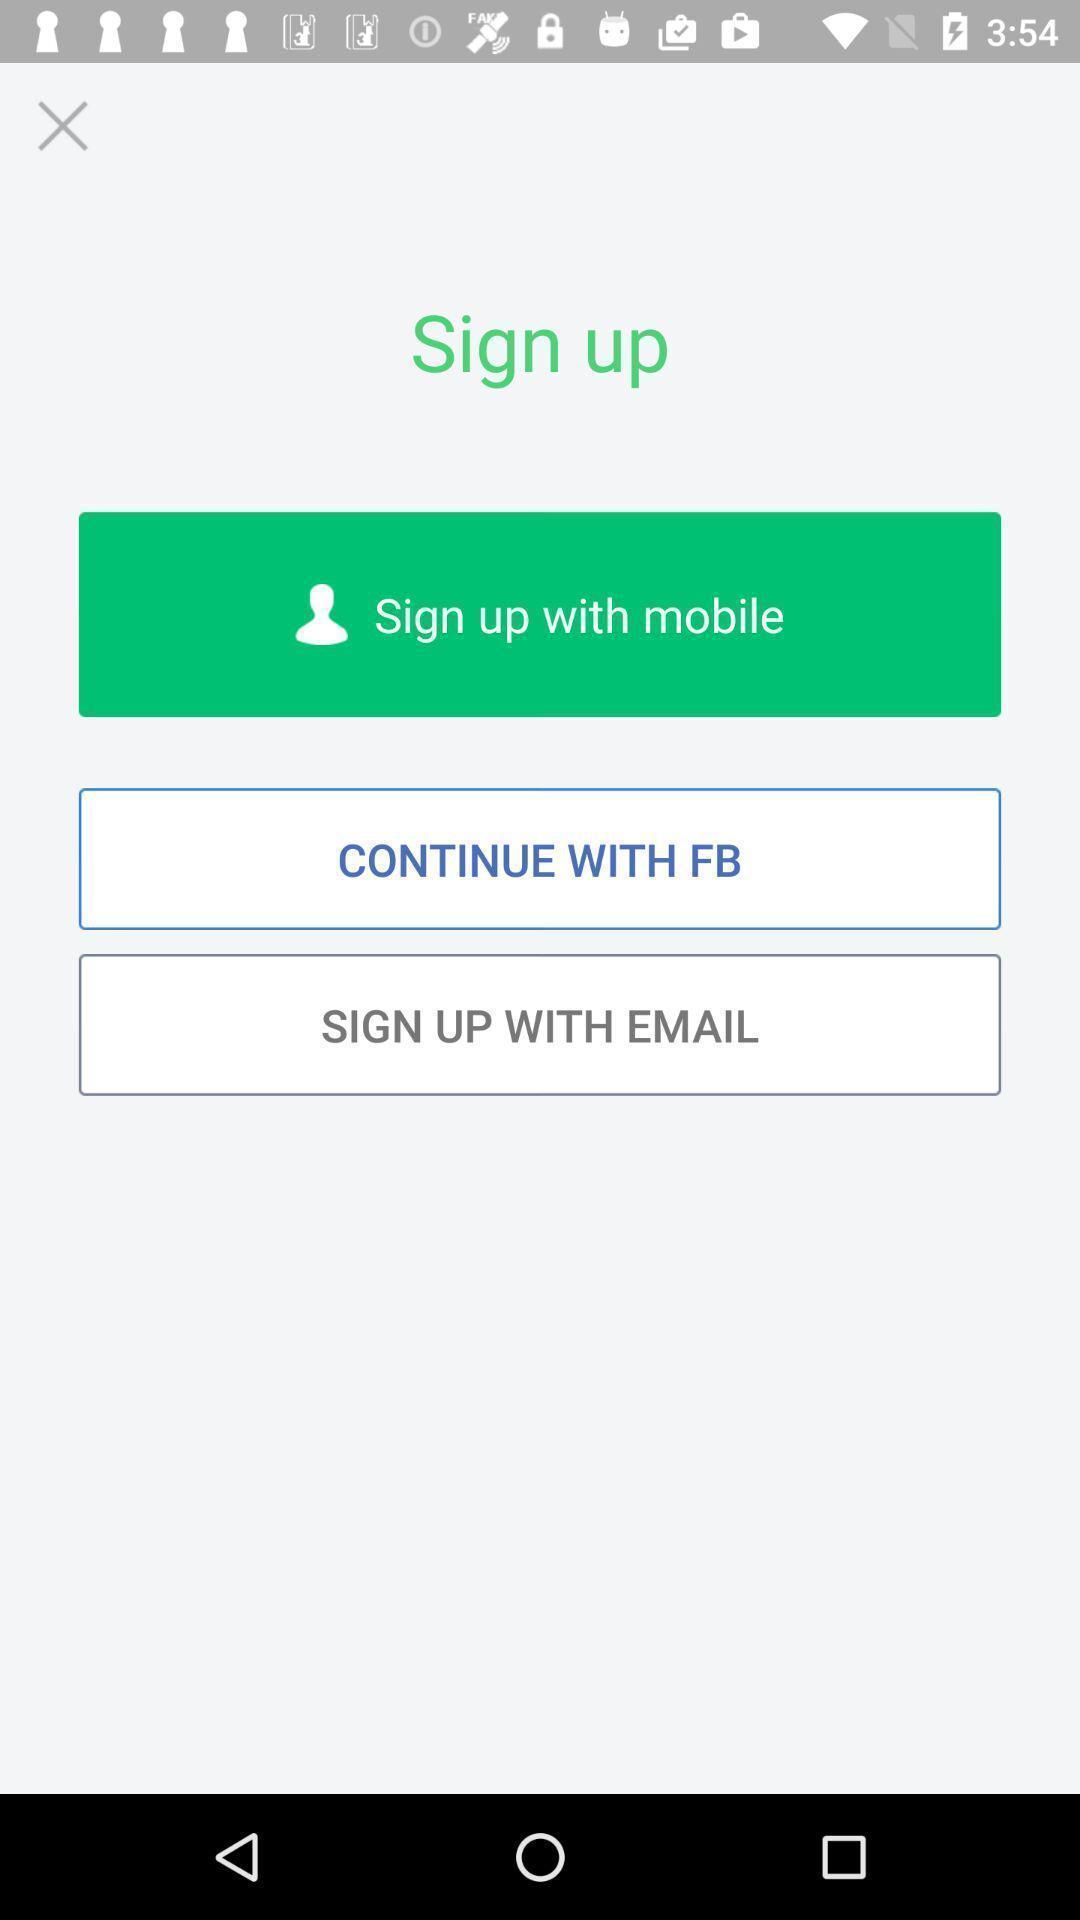What can you discern from this picture? Sign-up page. 